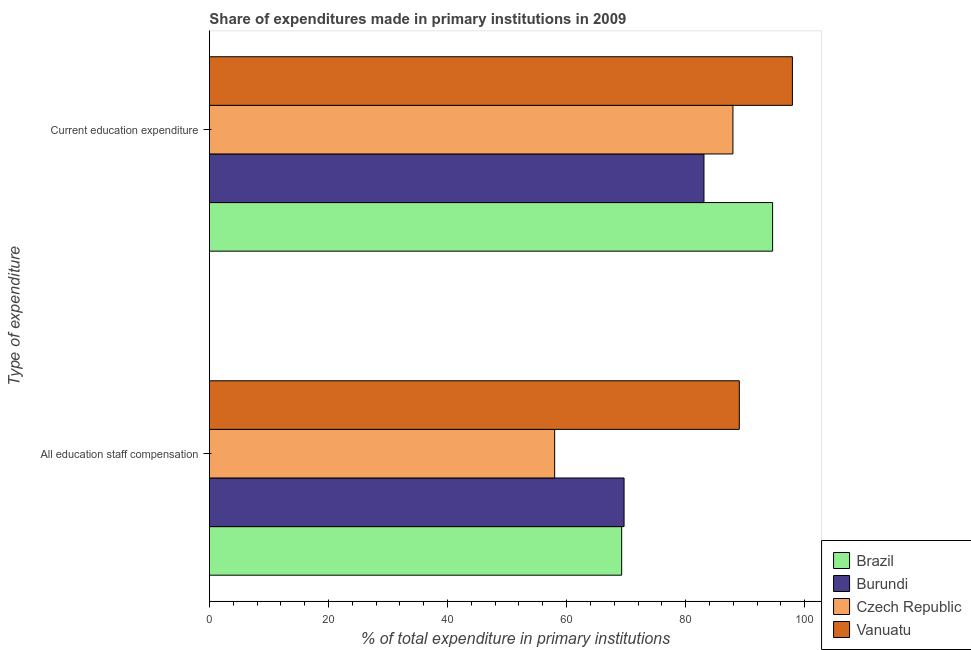Are the number of bars on each tick of the Y-axis equal?
Offer a terse response. Yes. How many bars are there on the 1st tick from the bottom?
Provide a short and direct response. 4. What is the label of the 1st group of bars from the top?
Provide a short and direct response. Current education expenditure. What is the expenditure in staff compensation in Czech Republic?
Make the answer very short. 57.99. Across all countries, what is the maximum expenditure in staff compensation?
Offer a very short reply. 89.01. Across all countries, what is the minimum expenditure in staff compensation?
Keep it short and to the point. 57.99. In which country was the expenditure in staff compensation maximum?
Provide a short and direct response. Vanuatu. In which country was the expenditure in staff compensation minimum?
Keep it short and to the point. Czech Republic. What is the total expenditure in education in the graph?
Offer a very short reply. 363.55. What is the difference between the expenditure in education in Brazil and that in Czech Republic?
Make the answer very short. 6.66. What is the difference between the expenditure in education in Burundi and the expenditure in staff compensation in Czech Republic?
Your answer should be very brief. 25.08. What is the average expenditure in education per country?
Your response must be concise. 90.89. What is the difference between the expenditure in education and expenditure in staff compensation in Vanuatu?
Offer a terse response. 8.92. What is the ratio of the expenditure in staff compensation in Czech Republic to that in Burundi?
Provide a short and direct response. 0.83. Is the expenditure in education in Czech Republic less than that in Vanuatu?
Offer a very short reply. Yes. In how many countries, is the expenditure in education greater than the average expenditure in education taken over all countries?
Keep it short and to the point. 2. What does the 3rd bar from the top in Current education expenditure represents?
Keep it short and to the point. Burundi. What does the 2nd bar from the bottom in All education staff compensation represents?
Ensure brevity in your answer.  Burundi. How many bars are there?
Offer a very short reply. 8. How many countries are there in the graph?
Provide a succinct answer. 4. Does the graph contain any zero values?
Your answer should be very brief. No. Does the graph contain grids?
Ensure brevity in your answer.  No. How many legend labels are there?
Your answer should be compact. 4. How are the legend labels stacked?
Give a very brief answer. Vertical. What is the title of the graph?
Offer a very short reply. Share of expenditures made in primary institutions in 2009. What is the label or title of the X-axis?
Provide a short and direct response. % of total expenditure in primary institutions. What is the label or title of the Y-axis?
Offer a terse response. Type of expenditure. What is the % of total expenditure in primary institutions of Brazil in All education staff compensation?
Offer a terse response. 69.25. What is the % of total expenditure in primary institutions in Burundi in All education staff compensation?
Offer a very short reply. 69.65. What is the % of total expenditure in primary institutions in Czech Republic in All education staff compensation?
Provide a succinct answer. 57.99. What is the % of total expenditure in primary institutions in Vanuatu in All education staff compensation?
Keep it short and to the point. 89.01. What is the % of total expenditure in primary institutions of Brazil in Current education expenditure?
Your answer should be very brief. 94.6. What is the % of total expenditure in primary institutions in Burundi in Current education expenditure?
Offer a very short reply. 83.07. What is the % of total expenditure in primary institutions of Czech Republic in Current education expenditure?
Your response must be concise. 87.94. What is the % of total expenditure in primary institutions in Vanuatu in Current education expenditure?
Offer a terse response. 97.93. Across all Type of expenditure, what is the maximum % of total expenditure in primary institutions of Brazil?
Keep it short and to the point. 94.6. Across all Type of expenditure, what is the maximum % of total expenditure in primary institutions in Burundi?
Your answer should be compact. 83.07. Across all Type of expenditure, what is the maximum % of total expenditure in primary institutions in Czech Republic?
Your answer should be compact. 87.94. Across all Type of expenditure, what is the maximum % of total expenditure in primary institutions in Vanuatu?
Ensure brevity in your answer.  97.93. Across all Type of expenditure, what is the minimum % of total expenditure in primary institutions of Brazil?
Make the answer very short. 69.25. Across all Type of expenditure, what is the minimum % of total expenditure in primary institutions in Burundi?
Your answer should be compact. 69.65. Across all Type of expenditure, what is the minimum % of total expenditure in primary institutions of Czech Republic?
Ensure brevity in your answer.  57.99. Across all Type of expenditure, what is the minimum % of total expenditure in primary institutions in Vanuatu?
Keep it short and to the point. 89.01. What is the total % of total expenditure in primary institutions of Brazil in the graph?
Your response must be concise. 163.86. What is the total % of total expenditure in primary institutions of Burundi in the graph?
Offer a very short reply. 152.73. What is the total % of total expenditure in primary institutions of Czech Republic in the graph?
Offer a very short reply. 145.93. What is the total % of total expenditure in primary institutions of Vanuatu in the graph?
Offer a very short reply. 186.94. What is the difference between the % of total expenditure in primary institutions in Brazil in All education staff compensation and that in Current education expenditure?
Your response must be concise. -25.35. What is the difference between the % of total expenditure in primary institutions of Burundi in All education staff compensation and that in Current education expenditure?
Offer a very short reply. -13.42. What is the difference between the % of total expenditure in primary institutions in Czech Republic in All education staff compensation and that in Current education expenditure?
Your response must be concise. -29.95. What is the difference between the % of total expenditure in primary institutions of Vanuatu in All education staff compensation and that in Current education expenditure?
Provide a succinct answer. -8.92. What is the difference between the % of total expenditure in primary institutions in Brazil in All education staff compensation and the % of total expenditure in primary institutions in Burundi in Current education expenditure?
Make the answer very short. -13.82. What is the difference between the % of total expenditure in primary institutions of Brazil in All education staff compensation and the % of total expenditure in primary institutions of Czech Republic in Current education expenditure?
Provide a succinct answer. -18.69. What is the difference between the % of total expenditure in primary institutions of Brazil in All education staff compensation and the % of total expenditure in primary institutions of Vanuatu in Current education expenditure?
Your answer should be very brief. -28.68. What is the difference between the % of total expenditure in primary institutions of Burundi in All education staff compensation and the % of total expenditure in primary institutions of Czech Republic in Current education expenditure?
Provide a succinct answer. -18.29. What is the difference between the % of total expenditure in primary institutions of Burundi in All education staff compensation and the % of total expenditure in primary institutions of Vanuatu in Current education expenditure?
Give a very brief answer. -28.28. What is the difference between the % of total expenditure in primary institutions in Czech Republic in All education staff compensation and the % of total expenditure in primary institutions in Vanuatu in Current education expenditure?
Give a very brief answer. -39.94. What is the average % of total expenditure in primary institutions in Brazil per Type of expenditure?
Provide a short and direct response. 81.93. What is the average % of total expenditure in primary institutions of Burundi per Type of expenditure?
Offer a very short reply. 76.36. What is the average % of total expenditure in primary institutions of Czech Republic per Type of expenditure?
Provide a succinct answer. 72.97. What is the average % of total expenditure in primary institutions in Vanuatu per Type of expenditure?
Your answer should be very brief. 93.47. What is the difference between the % of total expenditure in primary institutions in Brazil and % of total expenditure in primary institutions in Burundi in All education staff compensation?
Your answer should be compact. -0.4. What is the difference between the % of total expenditure in primary institutions in Brazil and % of total expenditure in primary institutions in Czech Republic in All education staff compensation?
Provide a succinct answer. 11.26. What is the difference between the % of total expenditure in primary institutions of Brazil and % of total expenditure in primary institutions of Vanuatu in All education staff compensation?
Your answer should be compact. -19.76. What is the difference between the % of total expenditure in primary institutions of Burundi and % of total expenditure in primary institutions of Czech Republic in All education staff compensation?
Make the answer very short. 11.66. What is the difference between the % of total expenditure in primary institutions in Burundi and % of total expenditure in primary institutions in Vanuatu in All education staff compensation?
Your answer should be very brief. -19.36. What is the difference between the % of total expenditure in primary institutions in Czech Republic and % of total expenditure in primary institutions in Vanuatu in All education staff compensation?
Offer a very short reply. -31.02. What is the difference between the % of total expenditure in primary institutions of Brazil and % of total expenditure in primary institutions of Burundi in Current education expenditure?
Give a very brief answer. 11.53. What is the difference between the % of total expenditure in primary institutions in Brazil and % of total expenditure in primary institutions in Czech Republic in Current education expenditure?
Your response must be concise. 6.66. What is the difference between the % of total expenditure in primary institutions in Brazil and % of total expenditure in primary institutions in Vanuatu in Current education expenditure?
Your answer should be compact. -3.33. What is the difference between the % of total expenditure in primary institutions of Burundi and % of total expenditure in primary institutions of Czech Republic in Current education expenditure?
Offer a terse response. -4.87. What is the difference between the % of total expenditure in primary institutions in Burundi and % of total expenditure in primary institutions in Vanuatu in Current education expenditure?
Ensure brevity in your answer.  -14.86. What is the difference between the % of total expenditure in primary institutions in Czech Republic and % of total expenditure in primary institutions in Vanuatu in Current education expenditure?
Provide a short and direct response. -9.99. What is the ratio of the % of total expenditure in primary institutions of Brazil in All education staff compensation to that in Current education expenditure?
Offer a terse response. 0.73. What is the ratio of the % of total expenditure in primary institutions of Burundi in All education staff compensation to that in Current education expenditure?
Provide a succinct answer. 0.84. What is the ratio of the % of total expenditure in primary institutions of Czech Republic in All education staff compensation to that in Current education expenditure?
Keep it short and to the point. 0.66. What is the ratio of the % of total expenditure in primary institutions in Vanuatu in All education staff compensation to that in Current education expenditure?
Your answer should be compact. 0.91. What is the difference between the highest and the second highest % of total expenditure in primary institutions of Brazil?
Your answer should be compact. 25.35. What is the difference between the highest and the second highest % of total expenditure in primary institutions in Burundi?
Ensure brevity in your answer.  13.42. What is the difference between the highest and the second highest % of total expenditure in primary institutions of Czech Republic?
Your answer should be very brief. 29.95. What is the difference between the highest and the second highest % of total expenditure in primary institutions in Vanuatu?
Offer a very short reply. 8.92. What is the difference between the highest and the lowest % of total expenditure in primary institutions in Brazil?
Ensure brevity in your answer.  25.35. What is the difference between the highest and the lowest % of total expenditure in primary institutions of Burundi?
Your answer should be compact. 13.42. What is the difference between the highest and the lowest % of total expenditure in primary institutions of Czech Republic?
Provide a short and direct response. 29.95. What is the difference between the highest and the lowest % of total expenditure in primary institutions of Vanuatu?
Provide a short and direct response. 8.92. 